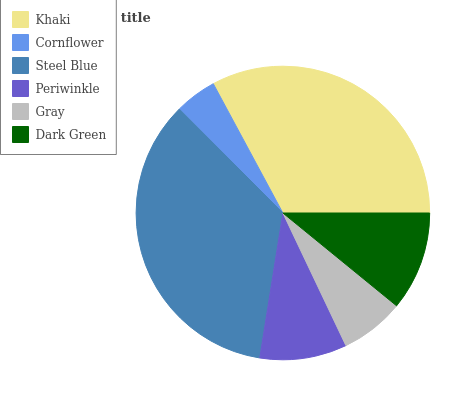Is Cornflower the minimum?
Answer yes or no. Yes. Is Steel Blue the maximum?
Answer yes or no. Yes. Is Steel Blue the minimum?
Answer yes or no. No. Is Cornflower the maximum?
Answer yes or no. No. Is Steel Blue greater than Cornflower?
Answer yes or no. Yes. Is Cornflower less than Steel Blue?
Answer yes or no. Yes. Is Cornflower greater than Steel Blue?
Answer yes or no. No. Is Steel Blue less than Cornflower?
Answer yes or no. No. Is Dark Green the high median?
Answer yes or no. Yes. Is Periwinkle the low median?
Answer yes or no. Yes. Is Steel Blue the high median?
Answer yes or no. No. Is Steel Blue the low median?
Answer yes or no. No. 